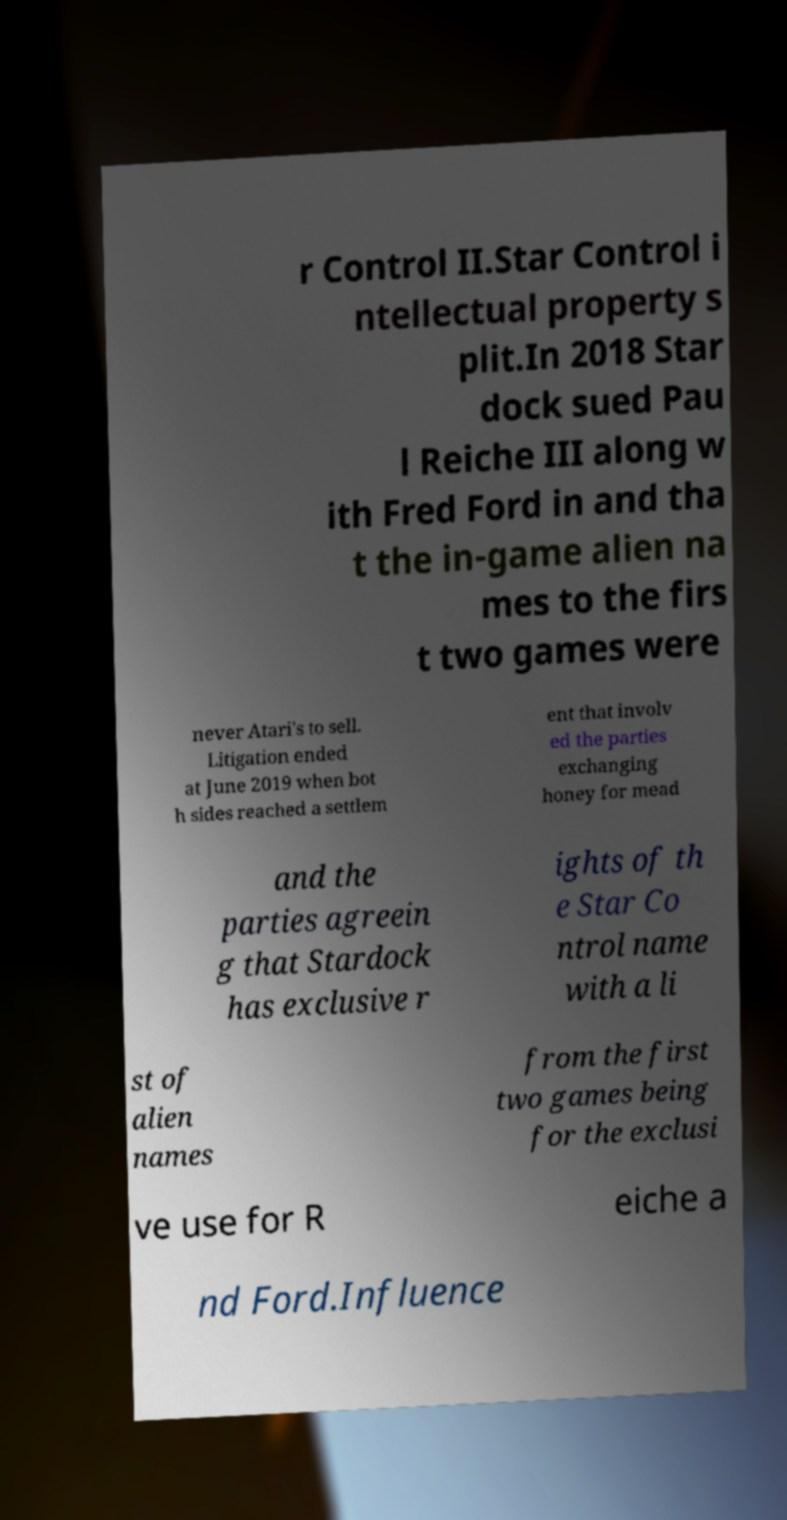What messages or text are displayed in this image? I need them in a readable, typed format. r Control II.Star Control i ntellectual property s plit.In 2018 Star dock sued Pau l Reiche III along w ith Fred Ford in and tha t the in-game alien na mes to the firs t two games were never Atari's to sell. Litigation ended at June 2019 when bot h sides reached a settlem ent that involv ed the parties exchanging honey for mead and the parties agreein g that Stardock has exclusive r ights of th e Star Co ntrol name with a li st of alien names from the first two games being for the exclusi ve use for R eiche a nd Ford.Influence 